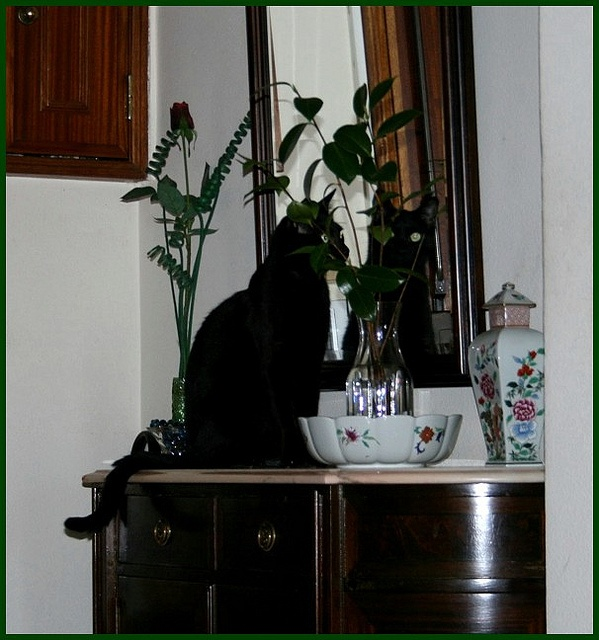Describe the objects in this image and their specific colors. I can see potted plant in darkgreen, black, darkgray, gray, and lightgray tones, cat in darkgreen, black, gray, and darkgray tones, potted plant in darkgreen, black, and gray tones, vase in darkgreen, gray, darkgray, and black tones, and vase in darkgreen, black, gray, darkgray, and white tones in this image. 